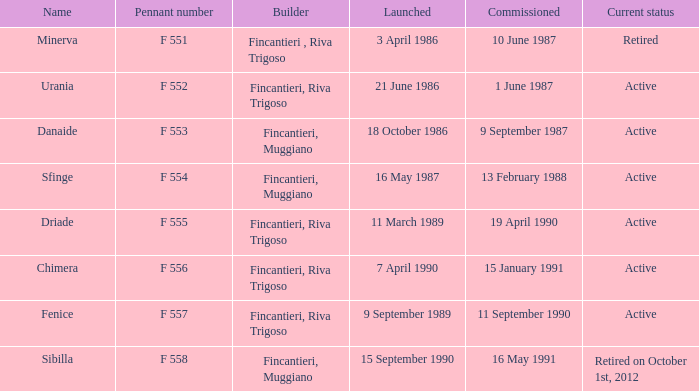Which constructor is currently retired? F 551. 